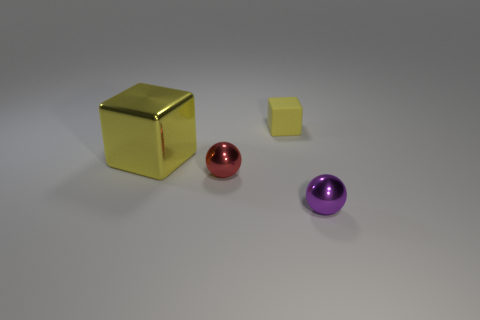There is a small object that is both behind the purple shiny ball and in front of the small cube; what is it made of?
Make the answer very short. Metal. Are there more purple metal things than gray rubber cylinders?
Provide a succinct answer. Yes. The ball that is on the right side of the block that is behind the cube that is left of the red ball is what color?
Your answer should be very brief. Purple. Is the sphere that is to the right of the small red shiny sphere made of the same material as the red object?
Keep it short and to the point. Yes. Are there any tiny blocks that have the same color as the large shiny object?
Provide a short and direct response. Yes. Is there a large block?
Ensure brevity in your answer.  Yes. Is the size of the metal sphere behind the purple ball the same as the tiny purple metallic ball?
Offer a terse response. Yes. Are there fewer tiny brown spheres than big cubes?
Keep it short and to the point. Yes. What is the shape of the big yellow metallic object left of the ball that is in front of the tiny metallic thing that is behind the purple ball?
Provide a short and direct response. Cube. Is there a purple thing that has the same material as the small yellow object?
Offer a terse response. No. 